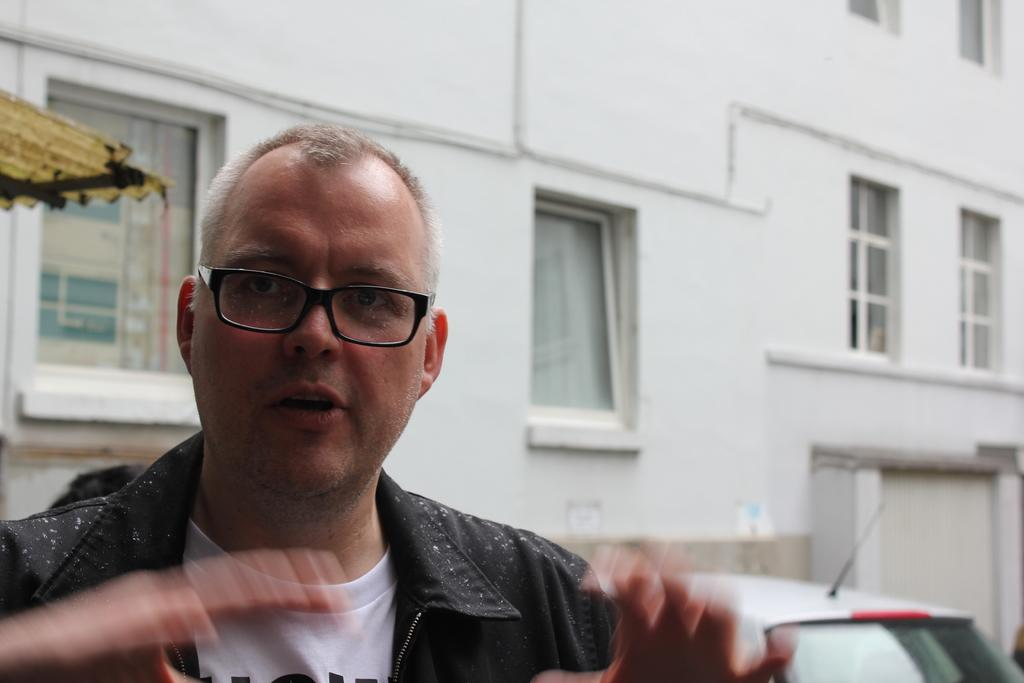What is the main subject of the image? There is a person in the image. What else can be seen in the image besides the person? There is a vehicle and a wall with windows in the image. Can you describe the wall in the image? The wall has windows in it. What is located on the left side of the image? There is an unspecified object on the left side of the image. What thoughts can be seen in the image? Thoughts cannot be seen in the image, as thoughts are not visible. 